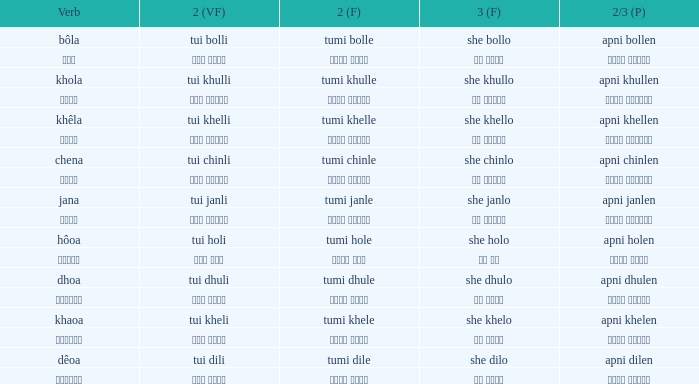Would you mind parsing the complete table? {'header': ['Verb', '2 (VF)', '2 (F)', '3 (F)', '2/3 (P)'], 'rows': [['bôla', 'tui bolli', 'tumi bolle', 'she bollo', 'apni bollen'], ['বলা', 'তুই বললি', 'তুমি বললে', 'সে বললো', 'আপনি বললেন'], ['khola', 'tui khulli', 'tumi khulle', 'she khullo', 'apni khullen'], ['খোলা', 'তুই খুললি', 'তুমি খুললে', 'সে খুললো', 'আপনি খুললেন'], ['khêla', 'tui khelli', 'tumi khelle', 'she khello', 'apni khellen'], ['খেলে', 'তুই খেললি', 'তুমি খেললে', 'সে খেললো', 'আপনি খেললেন'], ['chena', 'tui chinli', 'tumi chinle', 'she chinlo', 'apni chinlen'], ['চেনা', 'তুই চিনলি', 'তুমি চিনলে', 'সে চিনলো', 'আপনি চিনলেন'], ['jana', 'tui janli', 'tumi janle', 'she janlo', 'apni janlen'], ['জানা', 'তুই জানলি', 'তুমি জানলে', 'সে জানলে', 'আপনি জানলেন'], ['hôoa', 'tui holi', 'tumi hole', 'she holo', 'apni holen'], ['হওয়া', 'তুই হলি', 'তুমি হলে', 'সে হল', 'আপনি হলেন'], ['dhoa', 'tui dhuli', 'tumi dhule', 'she dhulo', 'apni dhulen'], ['ধোওয়া', 'তুই ধুলি', 'তুমি ধুলে', 'সে ধুলো', 'আপনি ধুলেন'], ['khaoa', 'tui kheli', 'tumi khele', 'she khelo', 'apni khelen'], ['খাওয়া', 'তুই খেলি', 'তুমি খেলে', 'সে খেলো', 'আপনি খেলেন'], ['dêoa', 'tui dili', 'tumi dile', 'she dilo', 'apni dilen'], ['দেওয়া', 'তুই দিলি', 'তুমি দিলে', 'সে দিলো', 'আপনি দিলেন']]} What is the verb for তুমি খেলে? খাওয়া. 